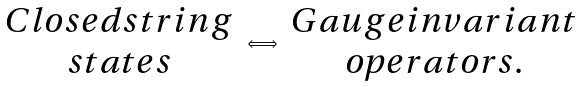<formula> <loc_0><loc_0><loc_500><loc_500>\begin{array} { c } C l o s e d s t r i n g \\ s t a t e s \end{array} \Longleftrightarrow \begin{array} { c } G a u g e i n v a r i a n t \\ o p e r a t o r s . \end{array}</formula> 